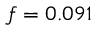Convert formula to latex. <formula><loc_0><loc_0><loc_500><loc_500>f = 0 . 0 9 1</formula> 